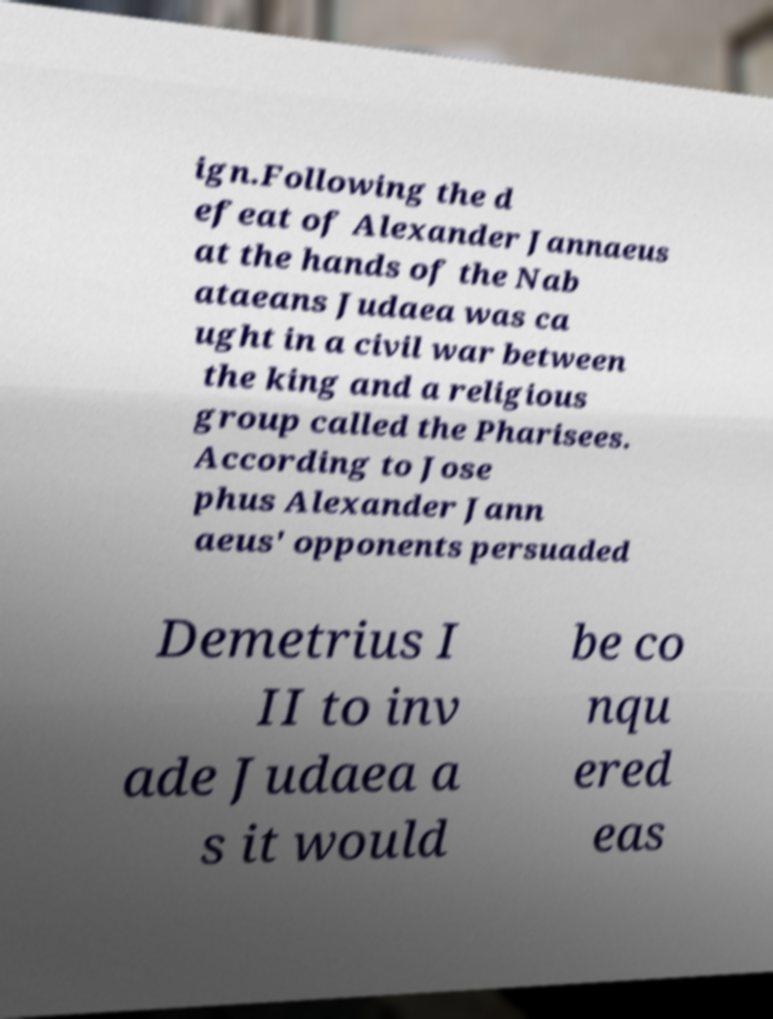Could you extract and type out the text from this image? ign.Following the d efeat of Alexander Jannaeus at the hands of the Nab ataeans Judaea was ca ught in a civil war between the king and a religious group called the Pharisees. According to Jose phus Alexander Jann aeus' opponents persuaded Demetrius I II to inv ade Judaea a s it would be co nqu ered eas 